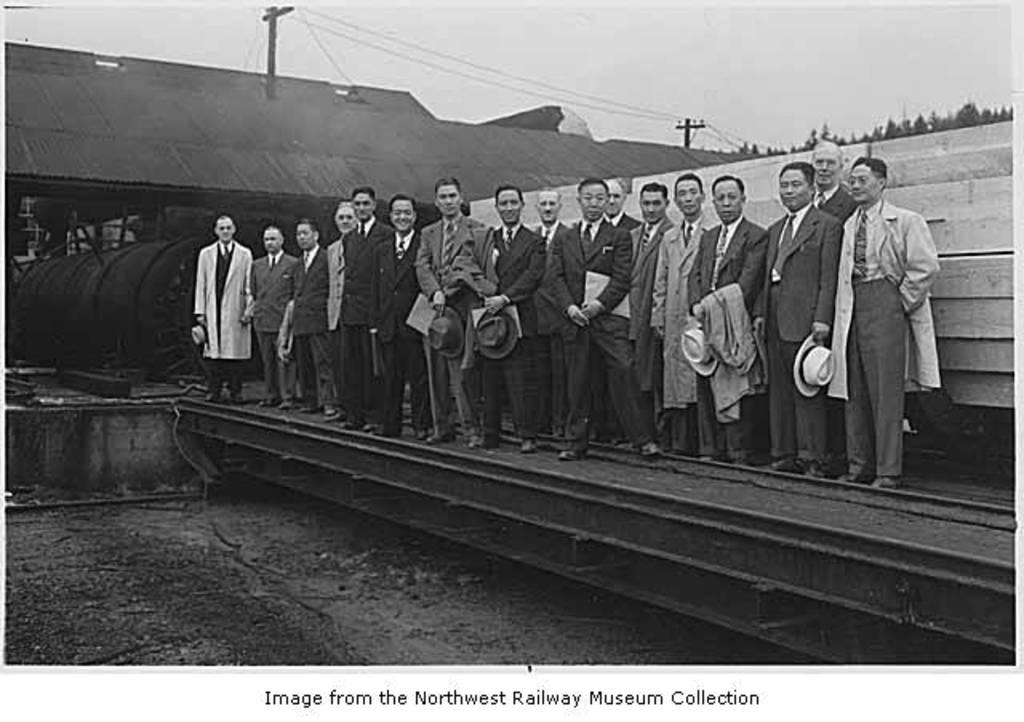What is the color scheme of the image? The image is black and white. What can be seen in the image besides the color scheme? There are people standing in the image, along with a train engine in the background, a shed, trees, and electric poles. What type of watch can be seen on the person's wrist in the image? There is no watch visible on anyone's wrist in the image. What songs are being sung by the people in the image? There is no indication in the image that the people are singing songs. 